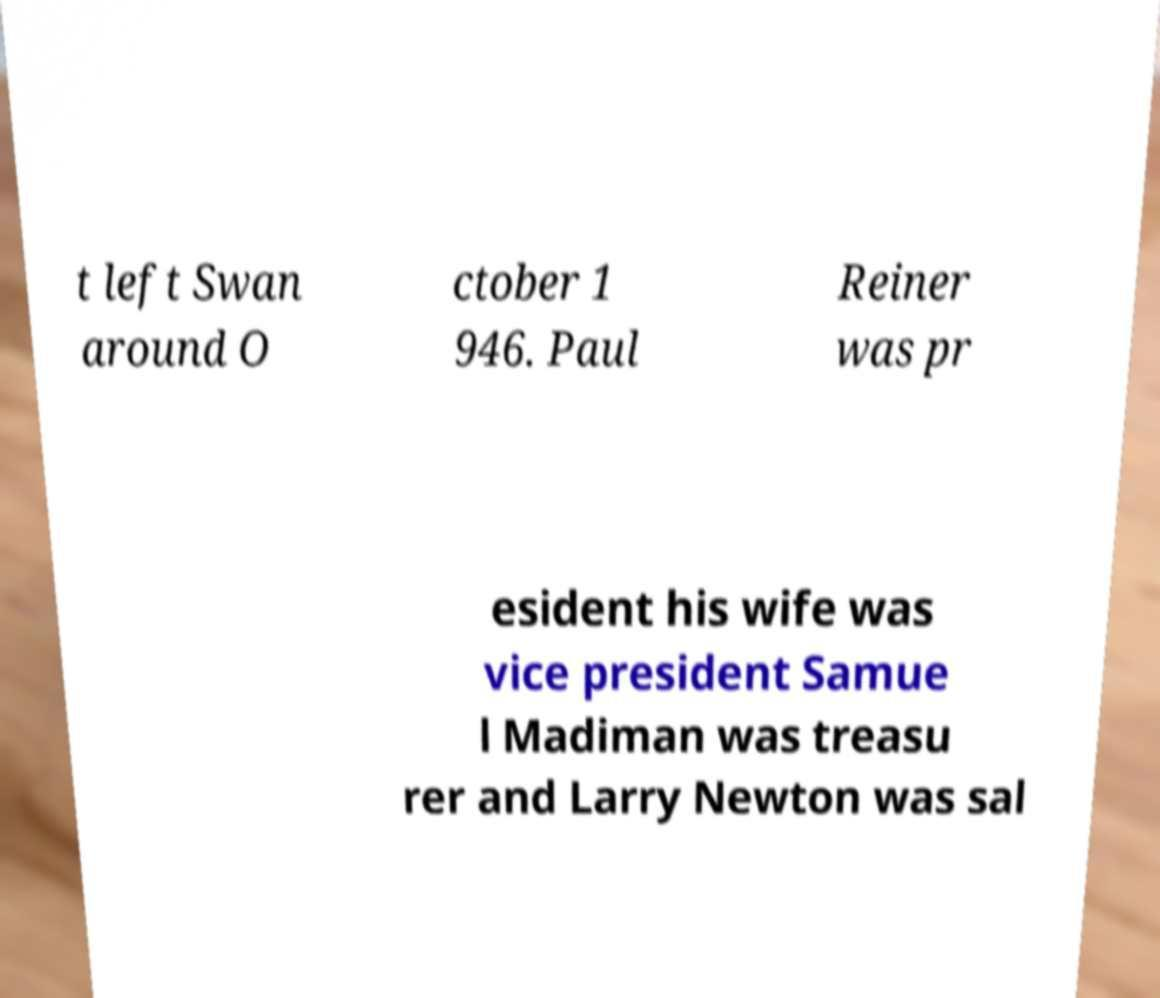What messages or text are displayed in this image? I need them in a readable, typed format. t left Swan around O ctober 1 946. Paul Reiner was pr esident his wife was vice president Samue l Madiman was treasu rer and Larry Newton was sal 